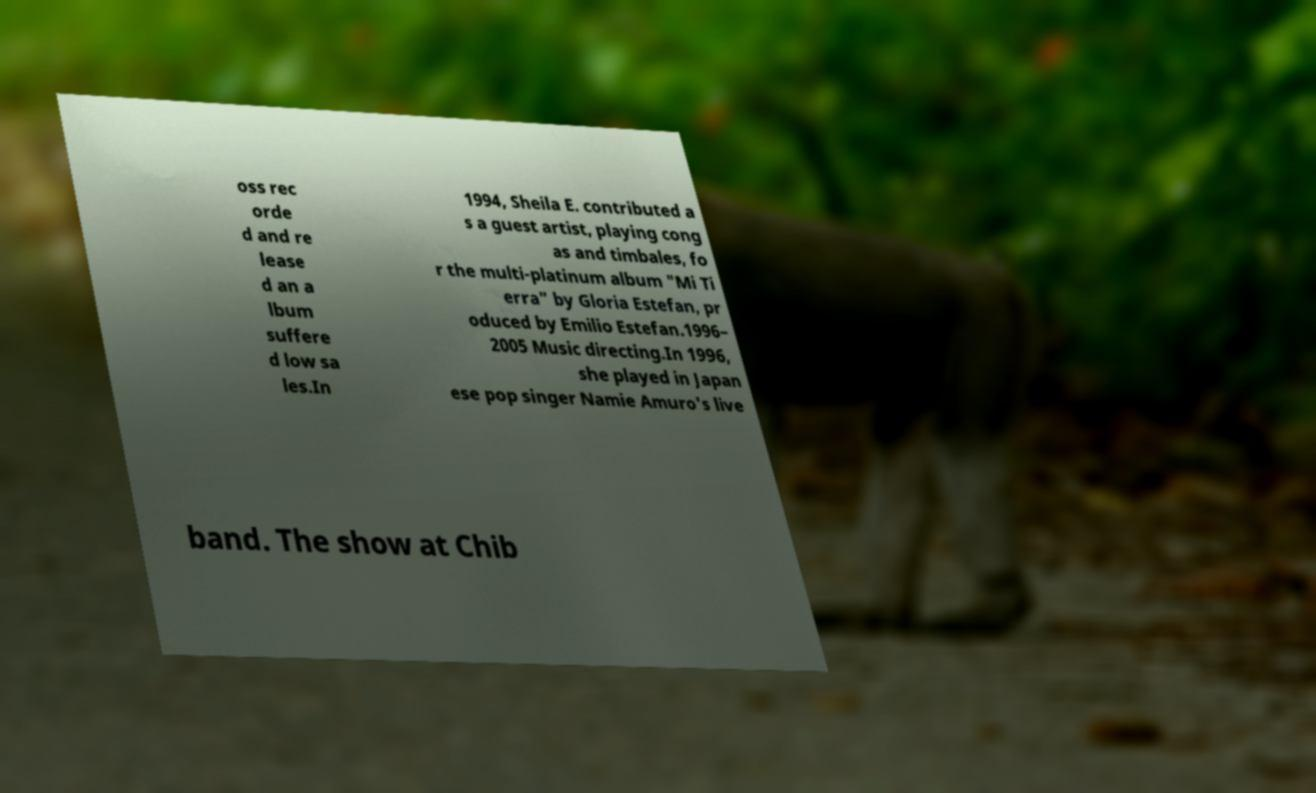Can you accurately transcribe the text from the provided image for me? oss rec orde d and re lease d an a lbum suffere d low sa les.In 1994, Sheila E. contributed a s a guest artist, playing cong as and timbales, fo r the multi-platinum album "Mi Ti erra" by Gloria Estefan, pr oduced by Emilio Estefan.1996– 2005 Music directing.In 1996, she played in Japan ese pop singer Namie Amuro's live band. The show at Chib 